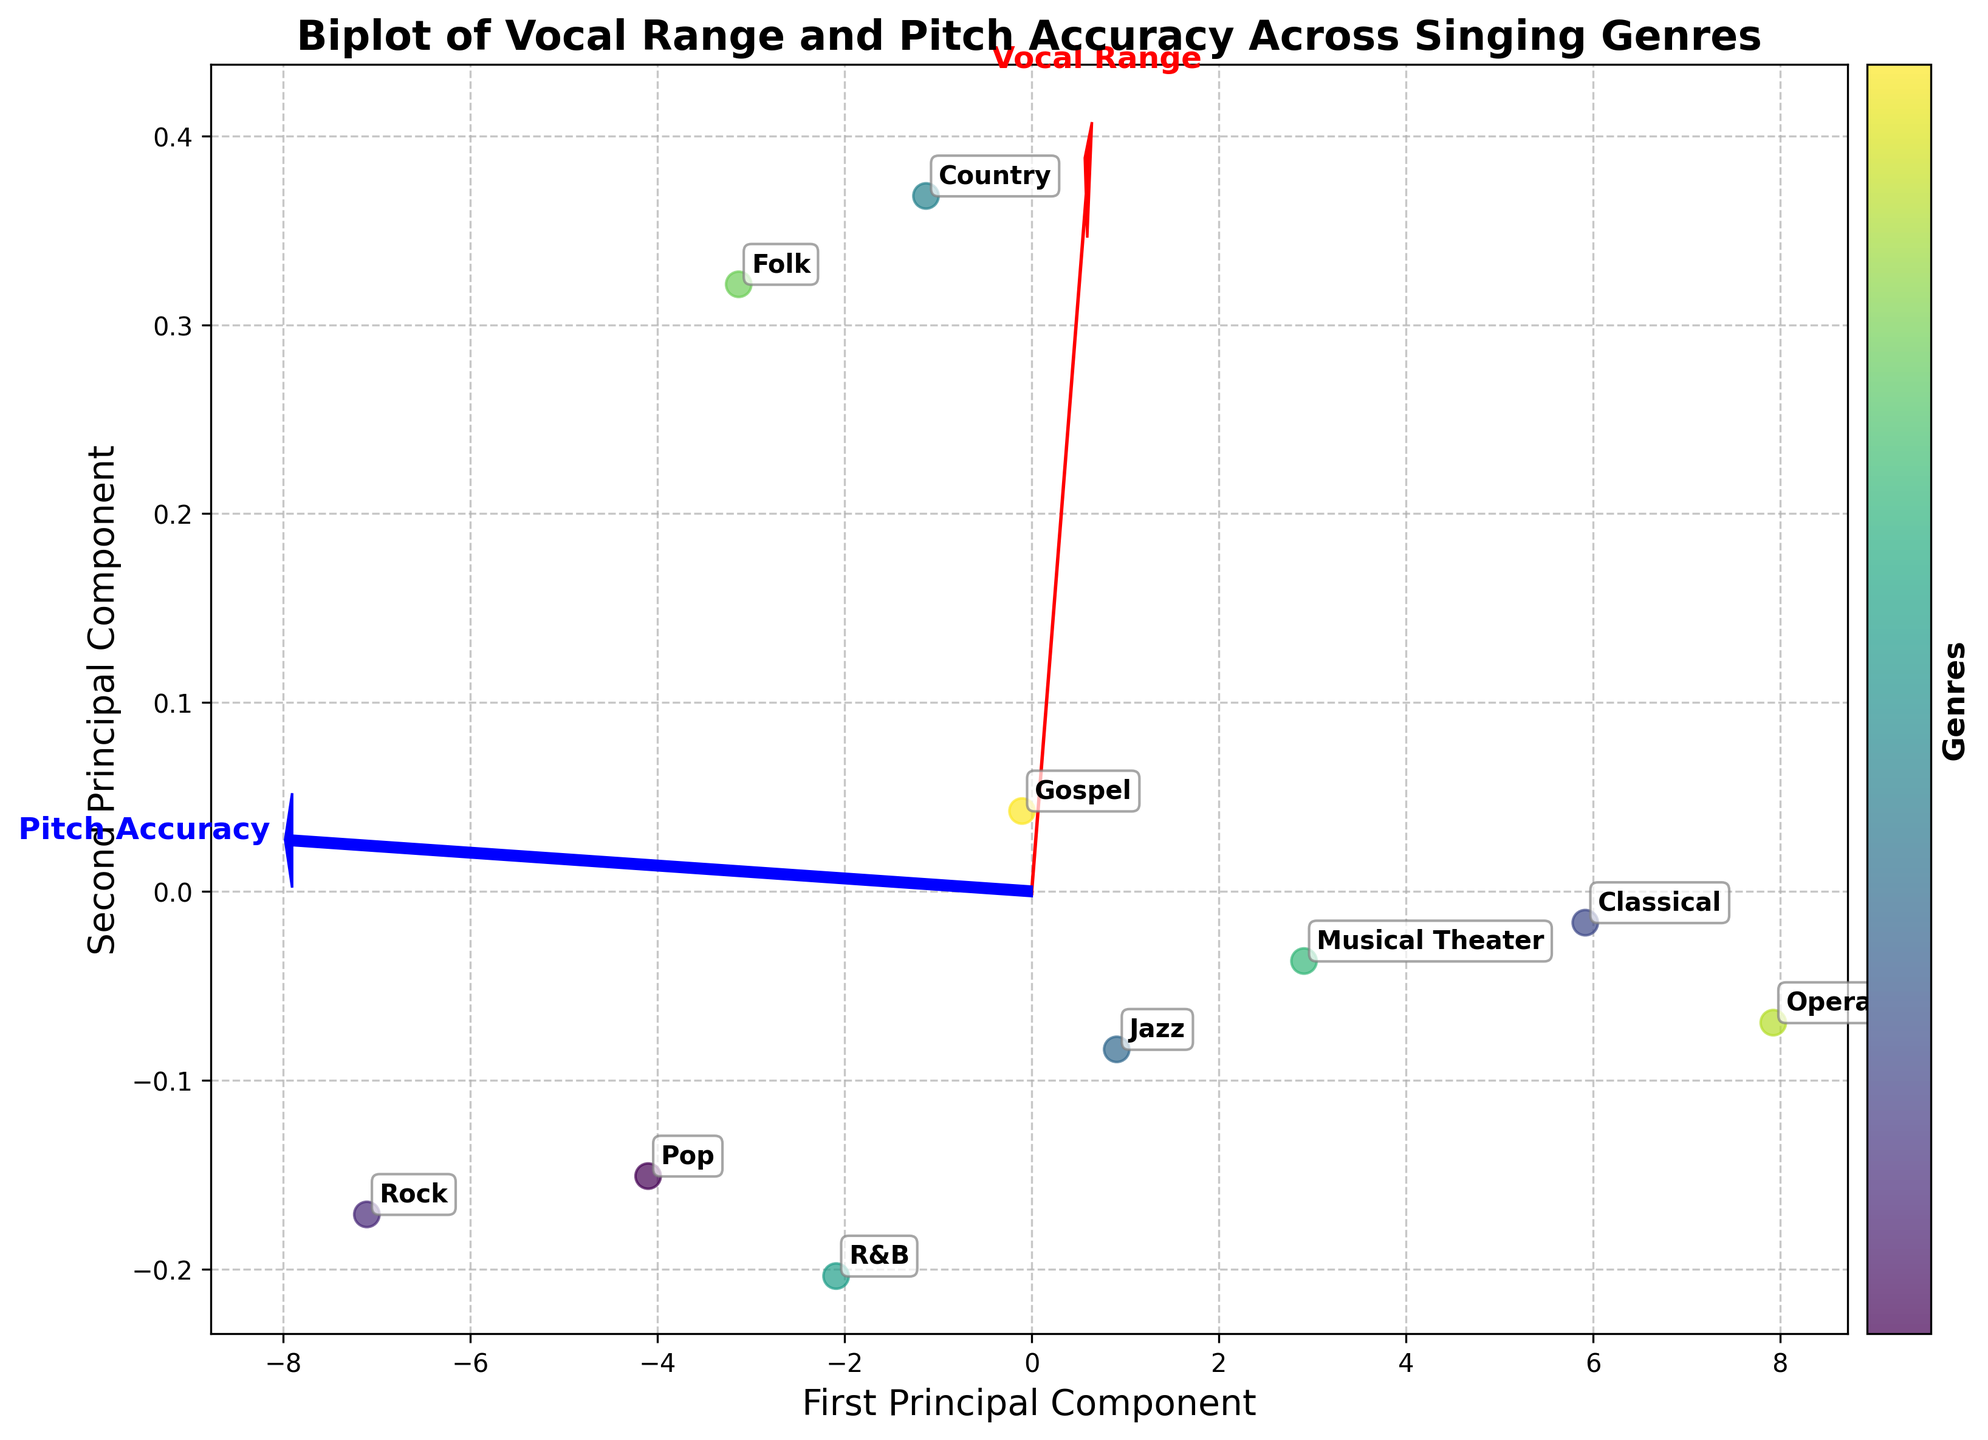What is the title of the plot? The title is usually displayed at the top of the plot, clearly indicating the subject matter it represents. In this case, it tells us the plot is about vocal range and pitch accuracy comparisons across different singing genres.
Answer: Biplot of Vocal Range and Pitch Accuracy Across Singing Genres How many singing genres are represented in the plot? You can determine the number of genres by counting the distinct labels or annotations on the plot.
Answer: 10 Which genre shows the highest pitch accuracy according to the plot? By examining where each genre is placed along the 'Pitch Accuracy' vector (blue arrow), the one farthest along this vector will have the highest pitch accuracy.
Answer: Opera Which genre shows the widest vocal range? The genre placed farthest along the 'Vocal Range' vector (red arrow) will have the widest vocal range.
Answer: Opera How are Pop and Rock genres positioned relative to each other on the plot? By looking at their positions in the plot, you can determine if Pop is to the left/right, above/below Rock. This involves checking their locations along both principal components.
Answer: Pop is to the right and slightly above Rock Between Classical and Jazz, which genre has better pitch accuracy and which has a wider vocal range? By comparing the positions of Classical and Jazz in both 'Pitch Accuracy' and 'Vocal Range' directions (vectors), we can identify which genre excels in each characteristic.
Answer: Classical has both better pitch accuracy and wider vocal range Do any genres have similar positions on the plot? If so, which ones? You can identify similarities by looking for clusters or genres that are plotted close to each other, indicating similar vocal range and pitch accuracy characteristics.
Answer: Jazz and Gospel What principal components does the x-axis and y-axis represent? The axes in a biplot are usually labeled to represent the principal components computed from PCA; these will generally help in explaining the variance captured in the plot.
Answer: First Principal Component (x-axis) and Second Principal Component (y-axis) Are the direction and length of feature vectors important? If yes, how? Yes, the direction shows the influence of a feature on the principal components, while the length of the vector indicates the strength or importance of the feature in that direction.
Answer: Yes, direction shows influence, length indicates strength 